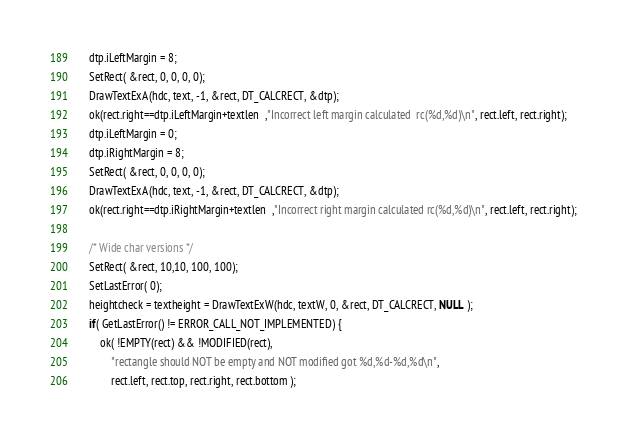<code> <loc_0><loc_0><loc_500><loc_500><_C_>    dtp.iLeftMargin = 8;
    SetRect( &rect, 0, 0, 0, 0);
    DrawTextExA(hdc, text, -1, &rect, DT_CALCRECT, &dtp);
    ok(rect.right==dtp.iLeftMargin+textlen  ,"Incorrect left margin calculated  rc(%d,%d)\n", rect.left, rect.right);
    dtp.iLeftMargin = 0;
    dtp.iRightMargin = 8;
    SetRect( &rect, 0, 0, 0, 0);
    DrawTextExA(hdc, text, -1, &rect, DT_CALCRECT, &dtp);
    ok(rect.right==dtp.iRightMargin+textlen  ,"Incorrect right margin calculated rc(%d,%d)\n", rect.left, rect.right);

    /* Wide char versions */
    SetRect( &rect, 10,10, 100, 100);
    SetLastError( 0);
    heightcheck = textheight = DrawTextExW(hdc, textW, 0, &rect, DT_CALCRECT, NULL );
    if( GetLastError() != ERROR_CALL_NOT_IMPLEMENTED) {
        ok( !EMPTY(rect) && !MODIFIED(rect),
            "rectangle should NOT be empty and NOT modified got %d,%d-%d,%d\n",
            rect.left, rect.top, rect.right, rect.bottom );</code> 